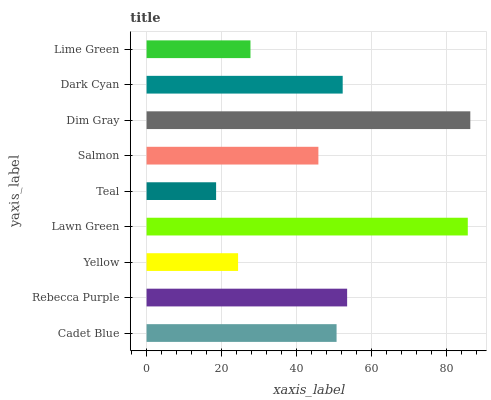Is Teal the minimum?
Answer yes or no. Yes. Is Dim Gray the maximum?
Answer yes or no. Yes. Is Rebecca Purple the minimum?
Answer yes or no. No. Is Rebecca Purple the maximum?
Answer yes or no. No. Is Rebecca Purple greater than Cadet Blue?
Answer yes or no. Yes. Is Cadet Blue less than Rebecca Purple?
Answer yes or no. Yes. Is Cadet Blue greater than Rebecca Purple?
Answer yes or no. No. Is Rebecca Purple less than Cadet Blue?
Answer yes or no. No. Is Cadet Blue the high median?
Answer yes or no. Yes. Is Cadet Blue the low median?
Answer yes or no. Yes. Is Lime Green the high median?
Answer yes or no. No. Is Yellow the low median?
Answer yes or no. No. 